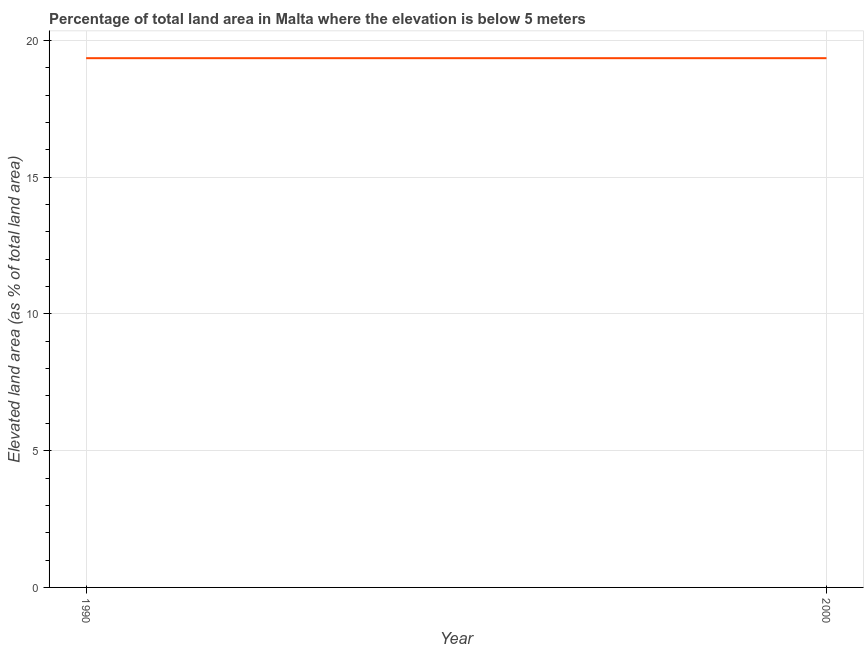What is the total elevated land area in 2000?
Your answer should be compact. 19.35. Across all years, what is the maximum total elevated land area?
Your answer should be very brief. 19.35. Across all years, what is the minimum total elevated land area?
Provide a short and direct response. 19.35. In which year was the total elevated land area maximum?
Your answer should be compact. 1990. In which year was the total elevated land area minimum?
Offer a very short reply. 1990. What is the sum of the total elevated land area?
Your answer should be very brief. 38.7. What is the difference between the total elevated land area in 1990 and 2000?
Your answer should be compact. 0. What is the average total elevated land area per year?
Your answer should be very brief. 19.35. What is the median total elevated land area?
Keep it short and to the point. 19.35. In how many years, is the total elevated land area greater than 18 %?
Keep it short and to the point. 2. What is the ratio of the total elevated land area in 1990 to that in 2000?
Give a very brief answer. 1. Does the total elevated land area monotonically increase over the years?
Your answer should be compact. No. How many lines are there?
Your answer should be very brief. 1. How many years are there in the graph?
Your answer should be very brief. 2. What is the difference between two consecutive major ticks on the Y-axis?
Make the answer very short. 5. Does the graph contain any zero values?
Your answer should be very brief. No. What is the title of the graph?
Make the answer very short. Percentage of total land area in Malta where the elevation is below 5 meters. What is the label or title of the X-axis?
Your answer should be compact. Year. What is the label or title of the Y-axis?
Offer a very short reply. Elevated land area (as % of total land area). What is the Elevated land area (as % of total land area) of 1990?
Make the answer very short. 19.35. What is the Elevated land area (as % of total land area) of 2000?
Offer a very short reply. 19.35. 